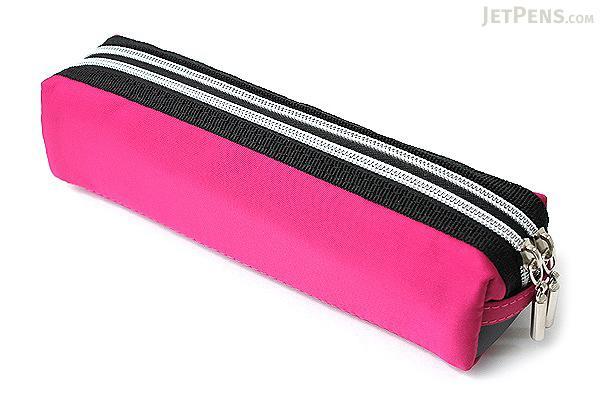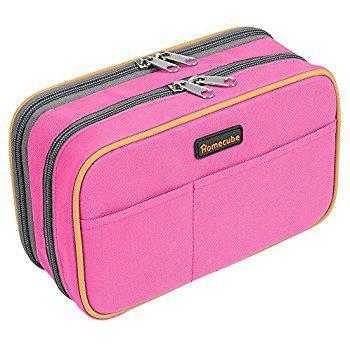The first image is the image on the left, the second image is the image on the right. For the images shown, is this caption "The image on the right has a double zipper." true? Answer yes or no. Yes. The first image is the image on the left, the second image is the image on the right. Given the left and right images, does the statement "One photo contains three or more pencil cases." hold true? Answer yes or no. No. The first image is the image on the left, the second image is the image on the right. Considering the images on both sides, is "the right image has a pencil pouch with 2 front pockets and two zippers on top" valid? Answer yes or no. Yes. The first image is the image on the left, the second image is the image on the right. Examine the images to the left and right. Is the description "An image shows a grouping of at least three pencil cases of the same size." accurate? Answer yes or no. No. 